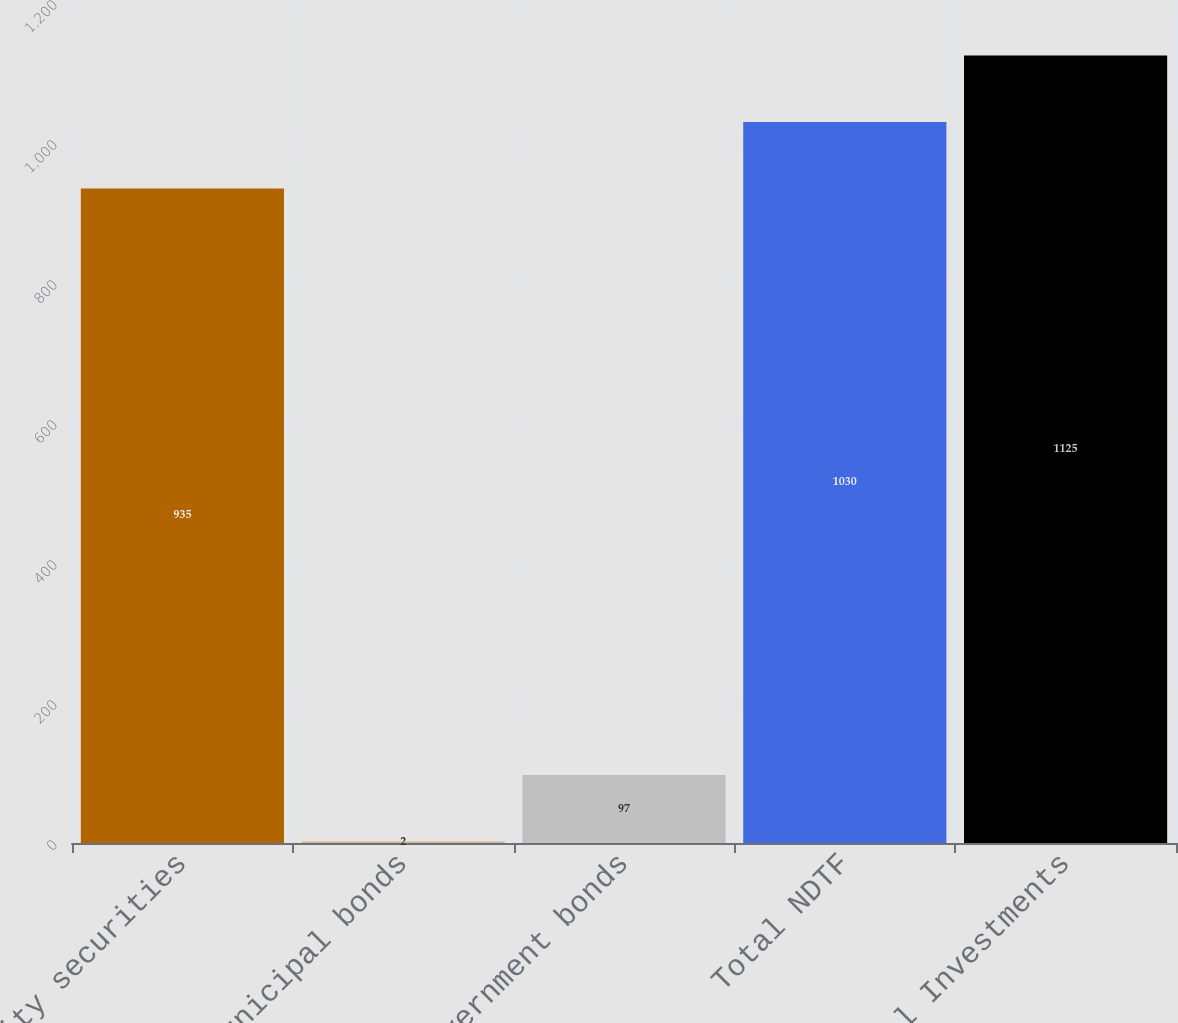<chart> <loc_0><loc_0><loc_500><loc_500><bar_chart><fcel>Equity securities<fcel>Municipal bonds<fcel>US government bonds<fcel>Total NDTF<fcel>Total Investments<nl><fcel>935<fcel>2<fcel>97<fcel>1030<fcel>1125<nl></chart> 